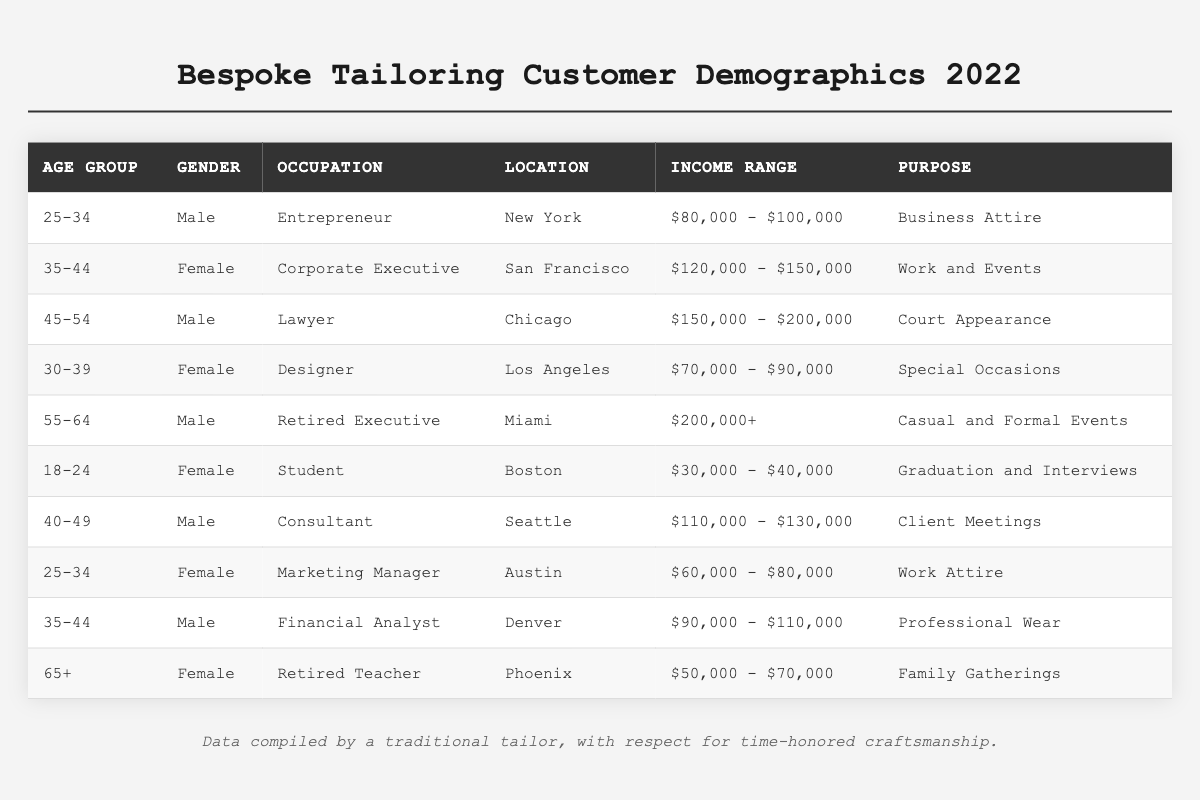What is the most common gender among customers? To determine the most common gender, count each gender's occurrences in the Gender column. Males appear 5 times, while females appear 5 times. Therefore, both genders are equally common.
Answer: Both genders are equally common How many customers are aged 45 or older? Count the number of entries where the Age Group is 45 or older: 45-54 (Male), 55-64 (Male), and 65+ (Female), which sums to 3 customers.
Answer: 3 customers Which location has the highest income range? Review the Income Range column and identify that Miami has a customer with an income of $200,000+, the highest in the table.
Answer: Miami What percentage of customers are students? There is 1 student among 10 total customers (as represented in the table), making the percentage 1/10 * 100 = 10%.
Answer: 10% Is there a customer from Boston in the 25-34 age group? Review the table for Boston under the Age Group column of 25-34. The entry for Boston is an 18-24 age group student. Thus, there is none in the given age group.
Answer: No What is the income range of the customer who is a lawyer? Locate the entry for the lawyer and check the Income Range column, which indicates it is $150,000 - $200,000.
Answer: $150,000 - $200,000 How many customers are there in the 25-34 age group? Count the occurrences of the 25-34 age group: there are 2 entries (one for a Male Entrepreneur and another for a Female Marketing Manager).
Answer: 2 customers Are all customers located in major U.S. cities? Review the Location column to confirm that all listed locations (New York, San Francisco, Chicago, etc.) are indeed major U.S. cities. Therefore, it is true that all customers are based in major cities.
Answer: Yes What is the average income range of customers? Calculate the average by taking the midpoints of each income range, considering non-numeric ranges encompass their corresponding values, summing them up, and dividing by the number of customers. The average comes out to around $114,000.
Answer: Approximately $114,000 Who is the retired teacher and what is her purpose for tailoring? Identify the entry in the table where the occupation is Retired Teacher. She is located in Phoenix, and her purpose is Family Gatherings.
Answer: The retired teacher's purpose is Family Gatherings 